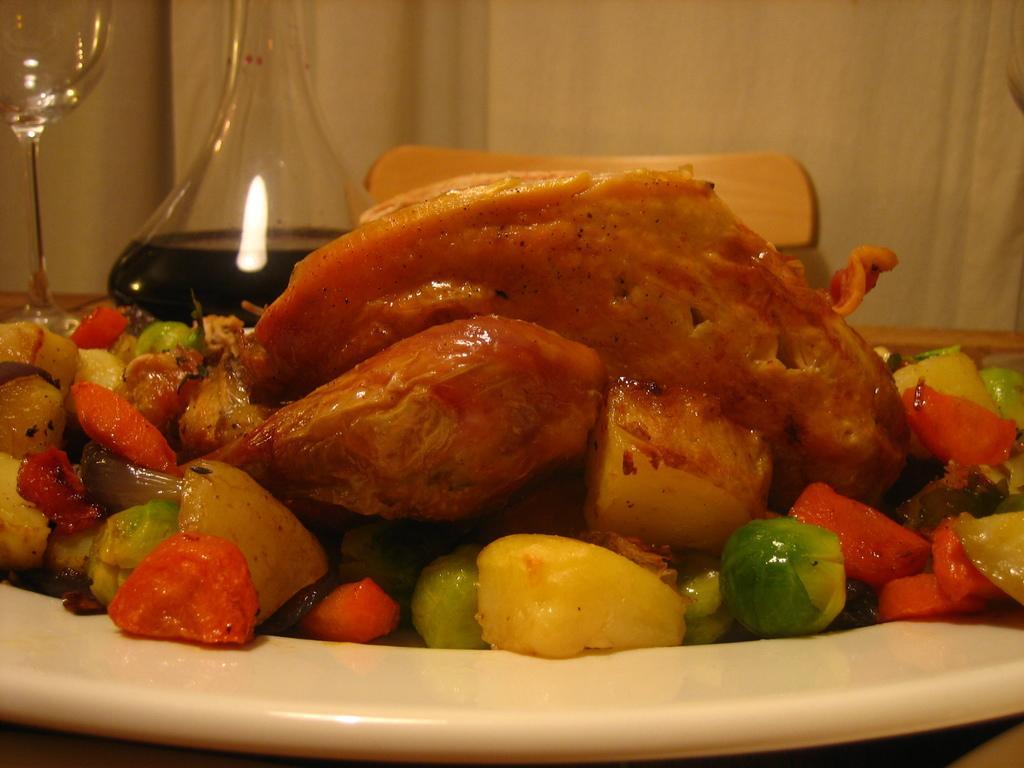In one or two sentences, can you explain what this image depicts? In the image there is some cooked food item and around that there are boiled vegetables served on a plate. 